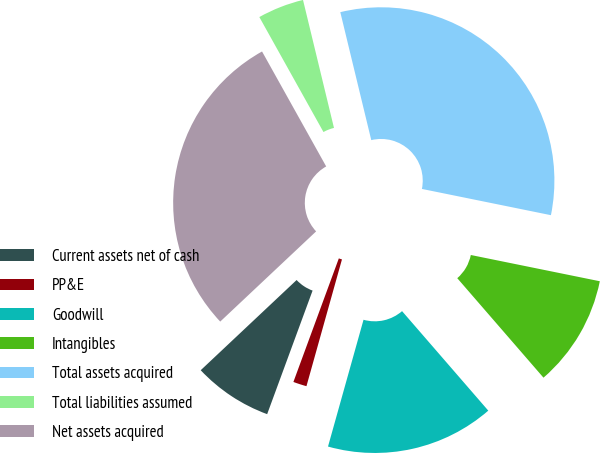<chart> <loc_0><loc_0><loc_500><loc_500><pie_chart><fcel>Current assets net of cash<fcel>PP&E<fcel>Goodwill<fcel>Intangibles<fcel>Total assets acquired<fcel>Total liabilities assumed<fcel>Net assets acquired<nl><fcel>7.38%<fcel>1.26%<fcel>15.71%<fcel>10.44%<fcel>31.97%<fcel>4.32%<fcel>28.91%<nl></chart> 